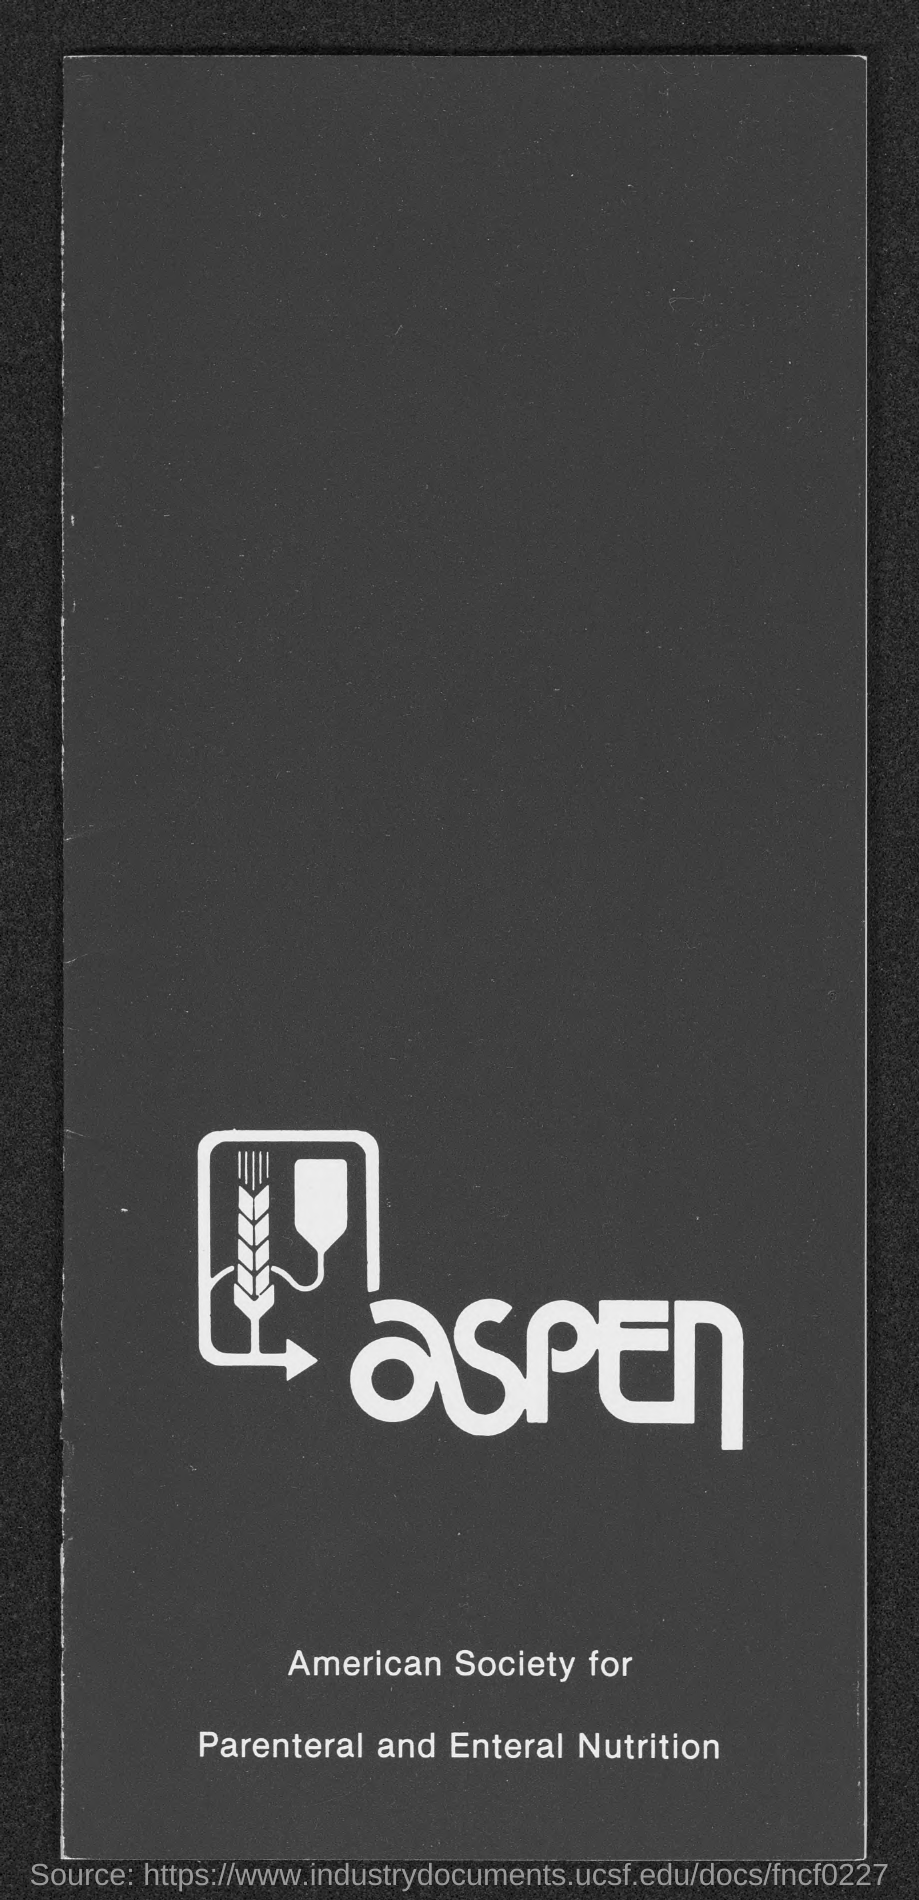What is the fullform of aspen?
Give a very brief answer. American Society for Parenteral and Enteral Nutrition. 